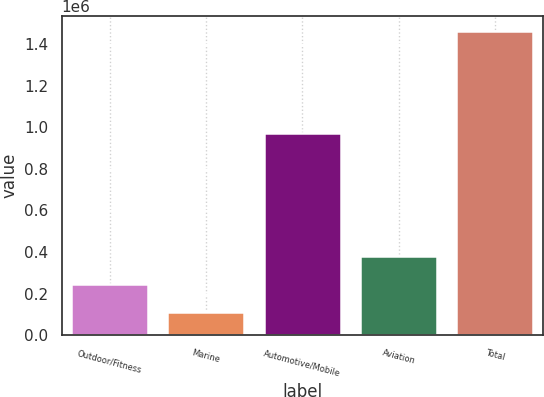<chart> <loc_0><loc_0><loc_500><loc_500><bar_chart><fcel>Outdoor/Fitness<fcel>Marine<fcel>Automotive/Mobile<fcel>Aviation<fcel>Total<nl><fcel>245478<fcel>110169<fcel>973205<fcel>380786<fcel>1.46326e+06<nl></chart> 